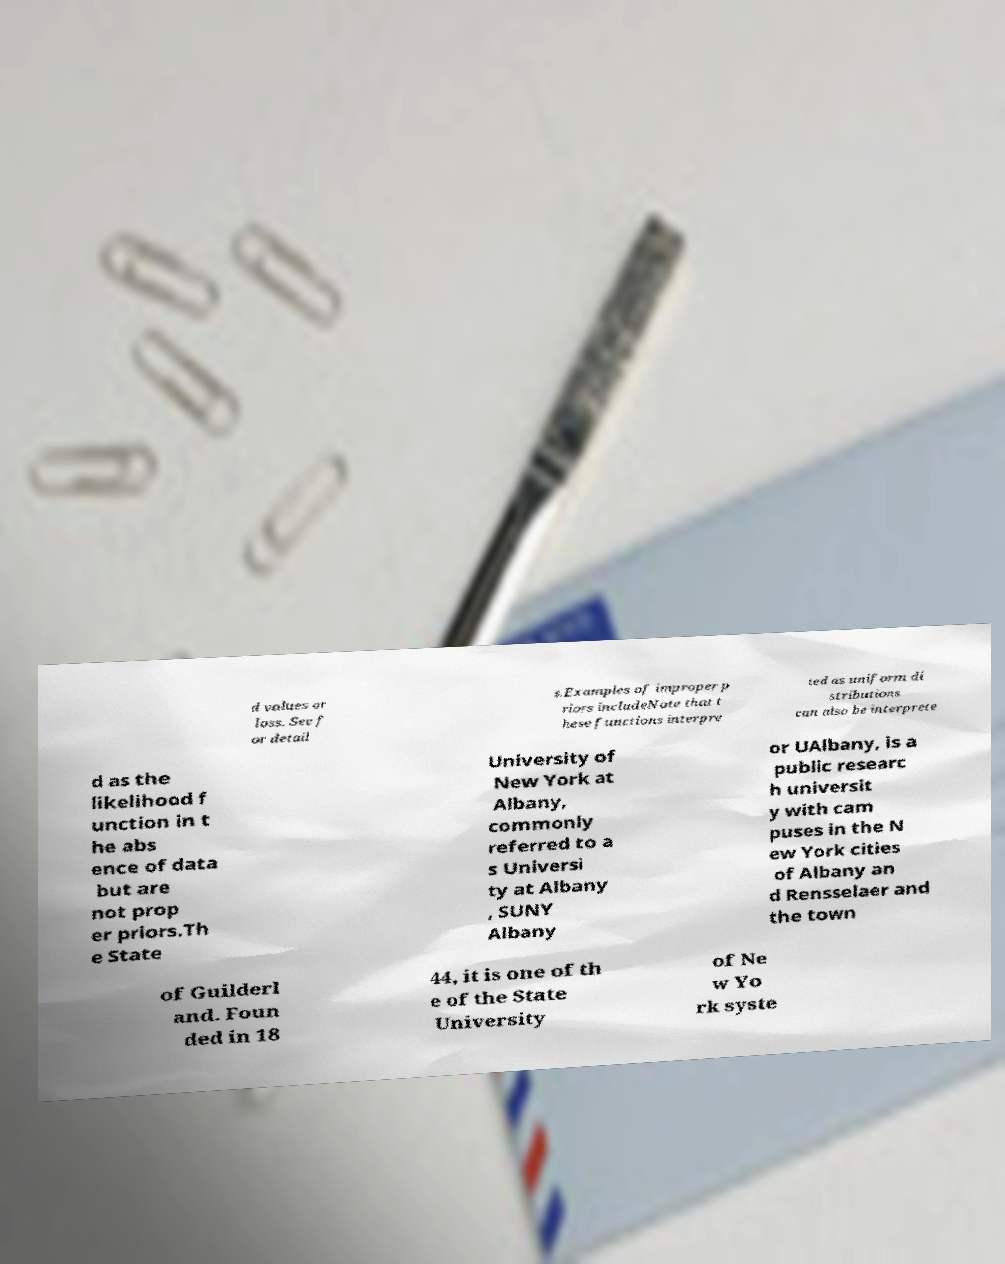Could you assist in decoding the text presented in this image and type it out clearly? d values or loss. See f or detail s.Examples of improper p riors includeNote that t hese functions interpre ted as uniform di stributions can also be interprete d as the likelihood f unction in t he abs ence of data but are not prop er priors.Th e State University of New York at Albany, commonly referred to a s Universi ty at Albany , SUNY Albany or UAlbany, is a public researc h universit y with cam puses in the N ew York cities of Albany an d Rensselaer and the town of Guilderl and. Foun ded in 18 44, it is one of th e of the State University of Ne w Yo rk syste 